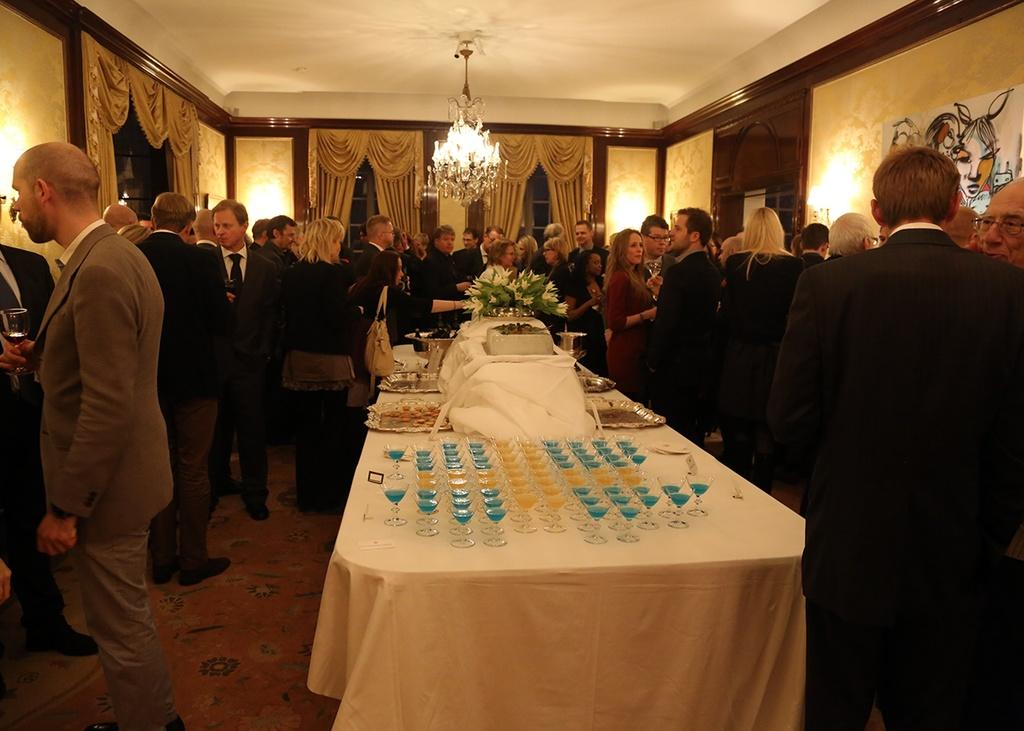How many people are in the image? There is a group of people in the image, but the exact number cannot be determined from the provided facts. What are some people doing with their hands in the image? Some people are holding glasses in their hands. What else can be found on the table besides glasses? There is food and flowers on the table. What type of lighting is present in the image? There is a chandelier light hanging in the image. What type of crate is visible in the image? There is no crate present in the image. What color is the powder on the table in the image? There is no powder present on the table in the image. 